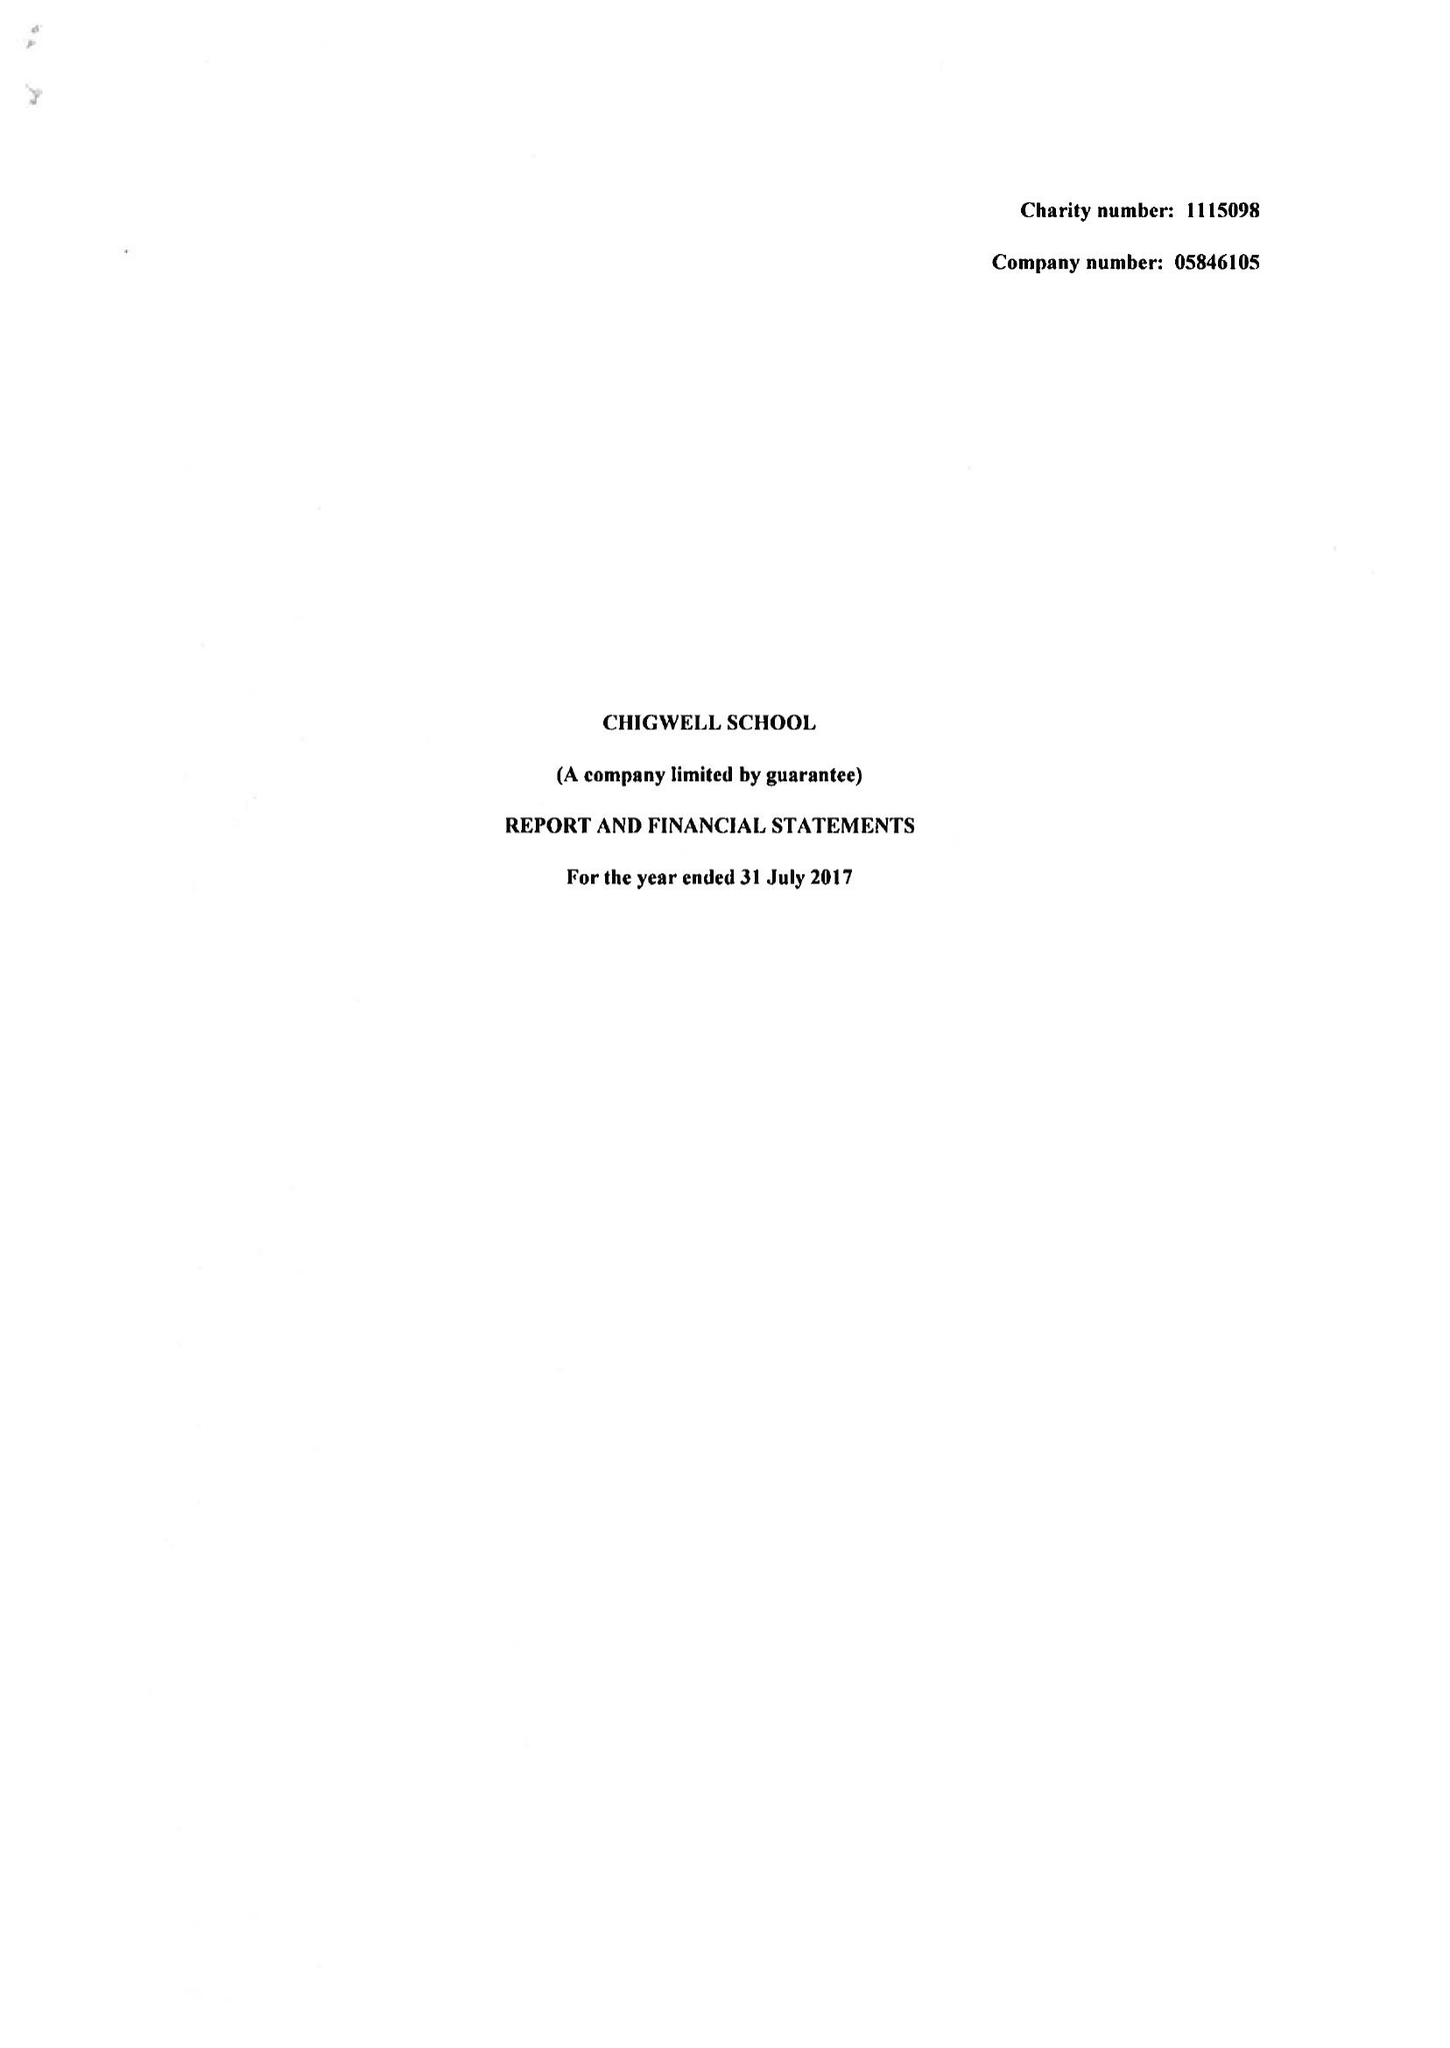What is the value for the charity_name?
Answer the question using a single word or phrase. Chigwell School 